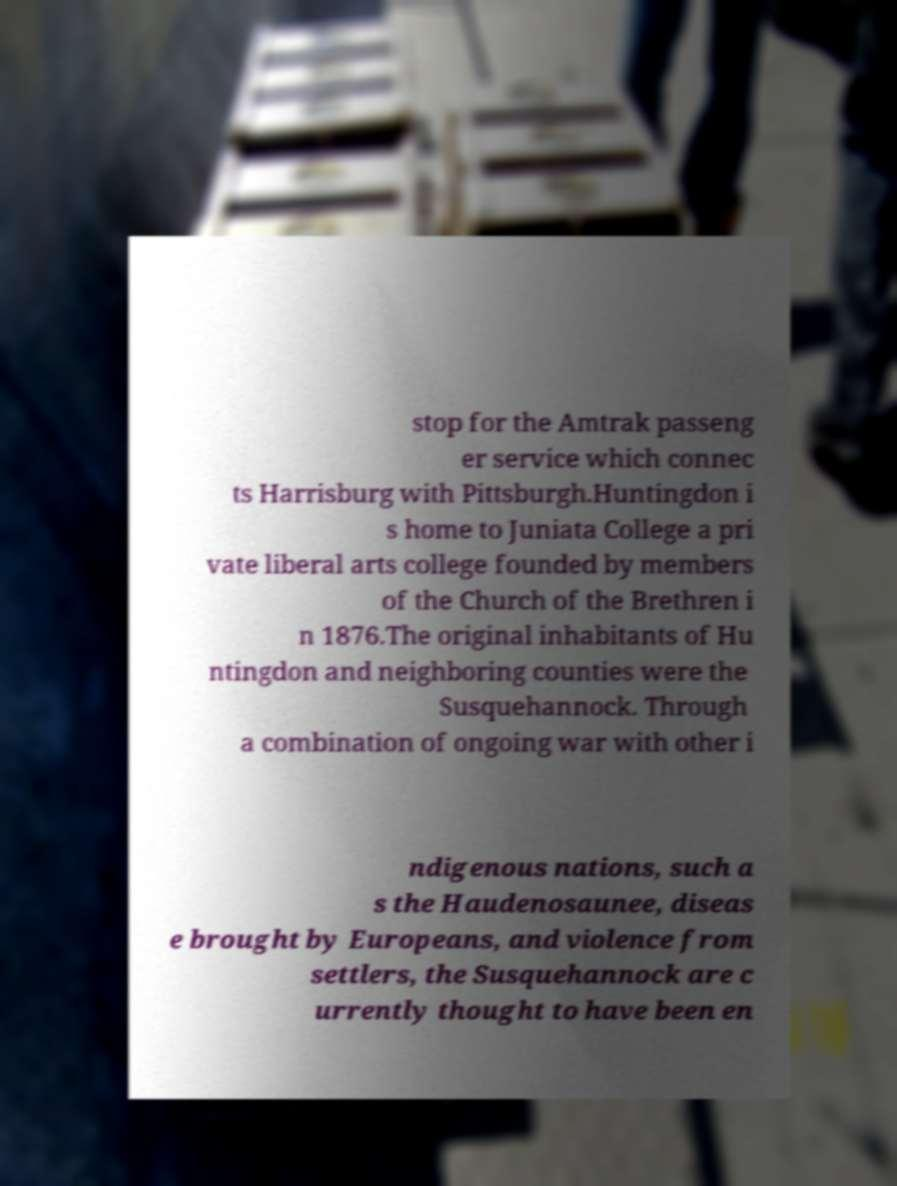Can you read and provide the text displayed in the image?This photo seems to have some interesting text. Can you extract and type it out for me? stop for the Amtrak passeng er service which connec ts Harrisburg with Pittsburgh.Huntingdon i s home to Juniata College a pri vate liberal arts college founded by members of the Church of the Brethren i n 1876.The original inhabitants of Hu ntingdon and neighboring counties were the Susquehannock. Through a combination of ongoing war with other i ndigenous nations, such a s the Haudenosaunee, diseas e brought by Europeans, and violence from settlers, the Susquehannock are c urrently thought to have been en 